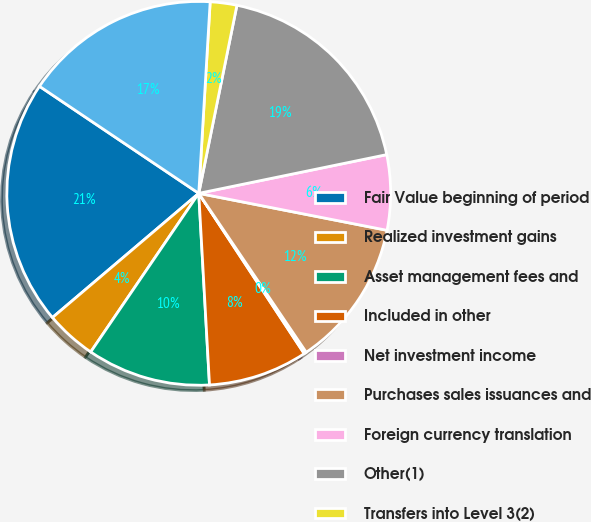Convert chart. <chart><loc_0><loc_0><loc_500><loc_500><pie_chart><fcel>Fair Value beginning of period<fcel>Realized investment gains<fcel>Asset management fees and<fcel>Included in other<fcel>Net investment income<fcel>Purchases sales issuances and<fcel>Foreign currency translation<fcel>Other(1)<fcel>Transfers into Level 3(2)<fcel>Transfers out of Level 3(2)<nl><fcel>20.62%<fcel>4.28%<fcel>10.41%<fcel>8.37%<fcel>0.2%<fcel>12.45%<fcel>6.32%<fcel>18.58%<fcel>2.24%<fcel>16.53%<nl></chart> 